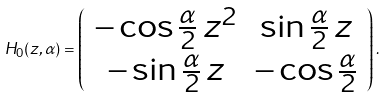<formula> <loc_0><loc_0><loc_500><loc_500>H _ { 0 } ( z , \alpha ) = \left ( \begin{array} { c c } - \cos \frac { \alpha } { 2 } \, z ^ { 2 } & \sin \frac { \alpha } { 2 } \, z \\ - \sin \frac { \alpha } { 2 } \, z & - \cos \frac { \alpha } { 2 } \end{array} \right ) .</formula> 